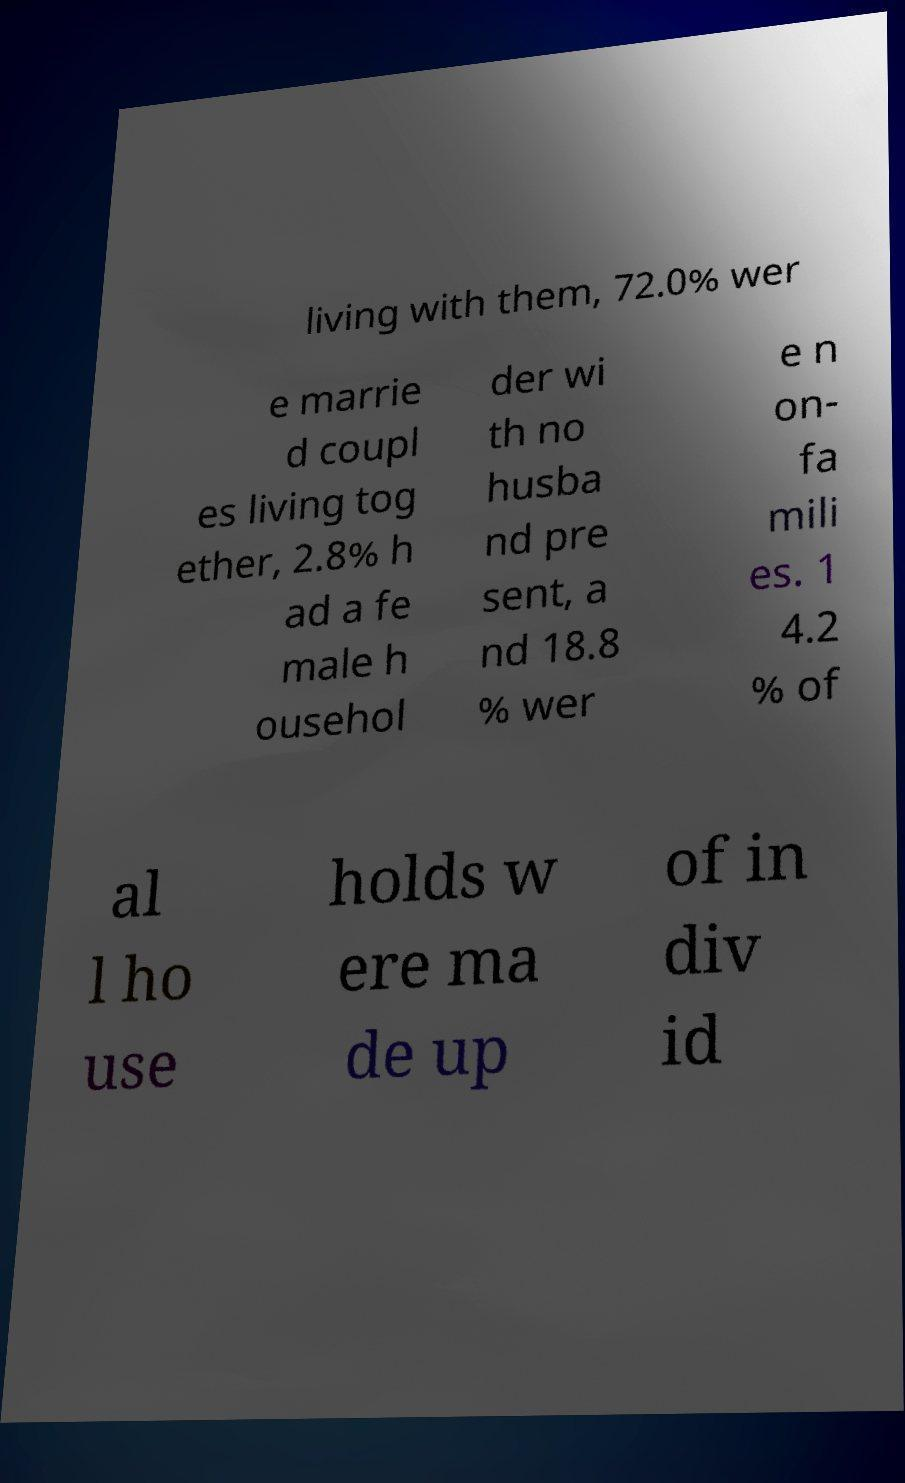Can you read and provide the text displayed in the image?This photo seems to have some interesting text. Can you extract and type it out for me? living with them, 72.0% wer e marrie d coupl es living tog ether, 2.8% h ad a fe male h ousehol der wi th no husba nd pre sent, a nd 18.8 % wer e n on- fa mili es. 1 4.2 % of al l ho use holds w ere ma de up of in div id 